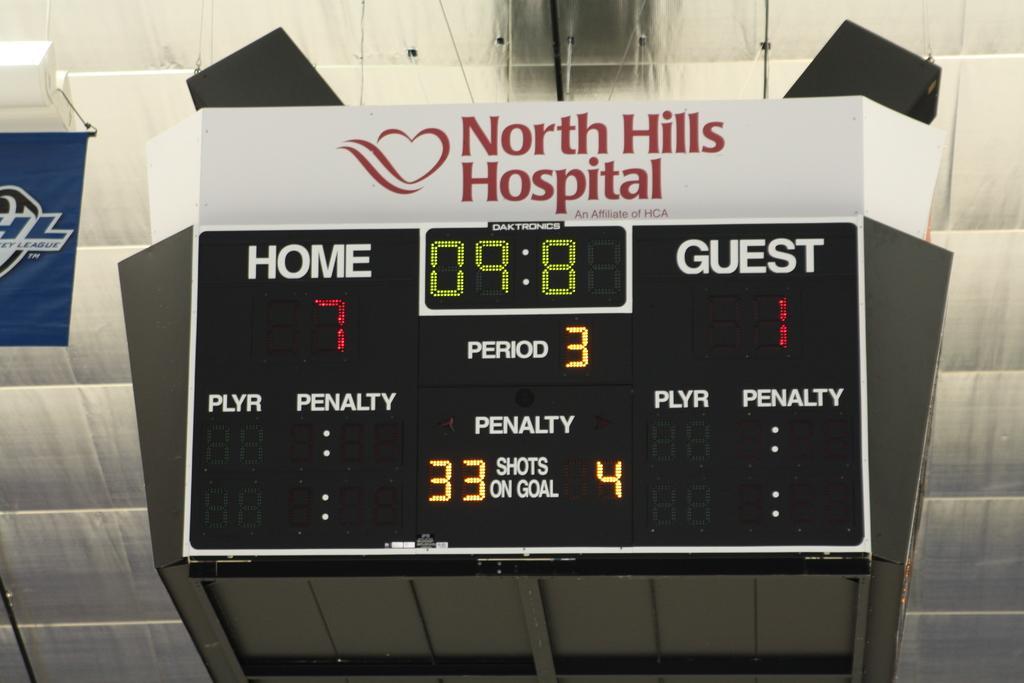How would you summarize this image in a sentence or two? In this image I can see the electronic scoreboard and I can see the name north hills hospital is written on it. To the left there is a blue color banner. In the background I can see the roof. 